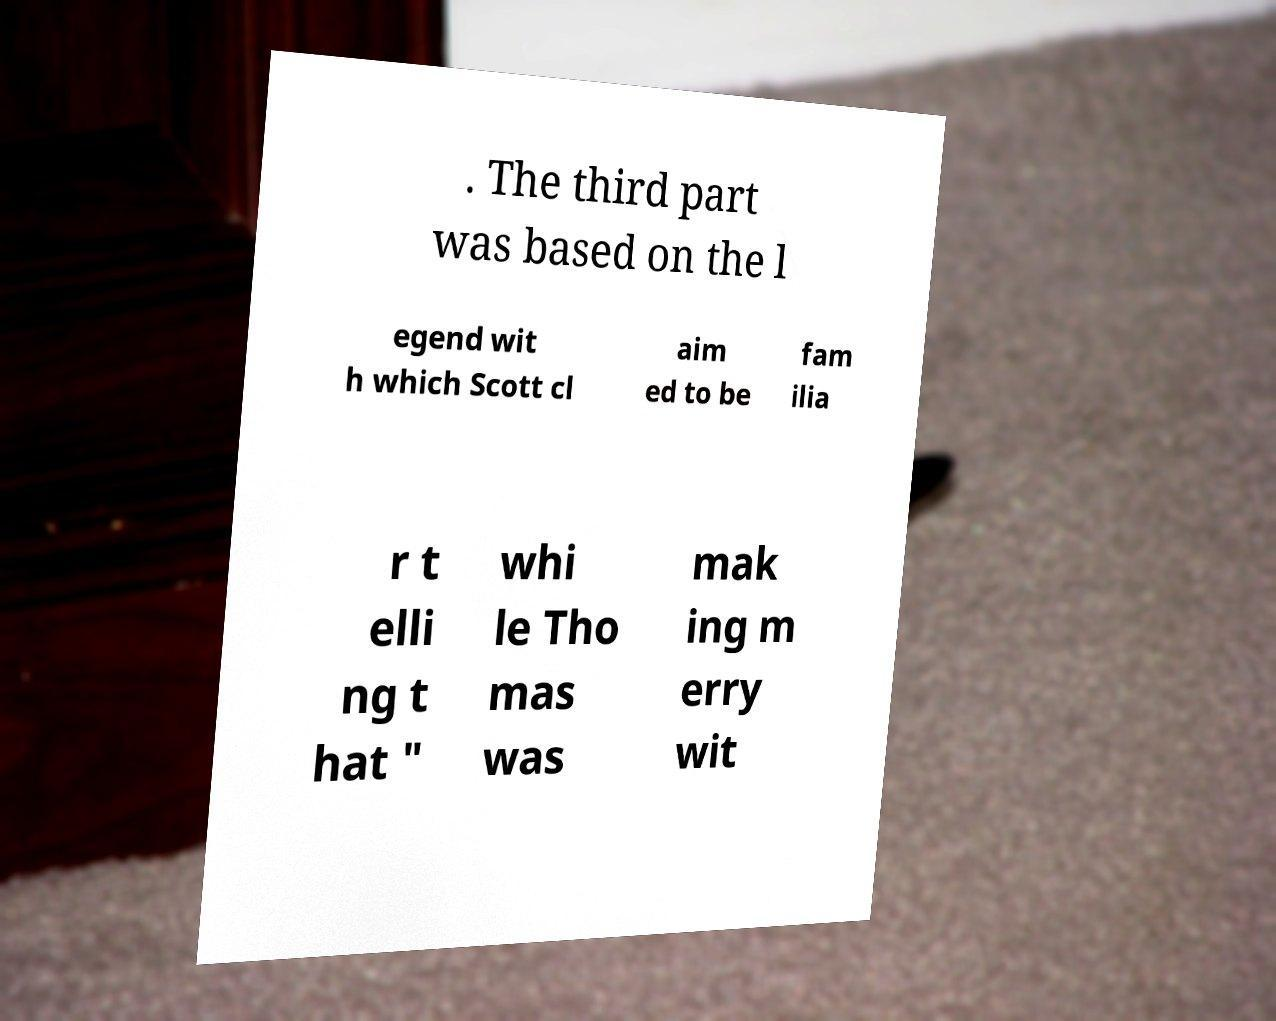Please read and relay the text visible in this image. What does it say? . The third part was based on the l egend wit h which Scott cl aim ed to be fam ilia r t elli ng t hat " whi le Tho mas was mak ing m erry wit 